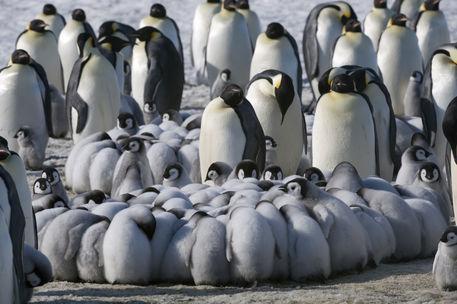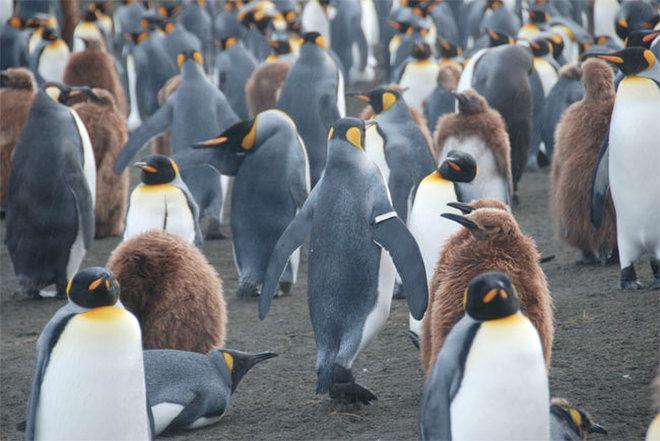The first image is the image on the left, the second image is the image on the right. Examine the images to the left and right. Is the description "In one image, the foreground includes at least one penguin fully covered in fuzzy brown." accurate? Answer yes or no. Yes. The first image is the image on the left, the second image is the image on the right. Given the left and right images, does the statement "There are penguins standing on snow." hold true? Answer yes or no. No. 